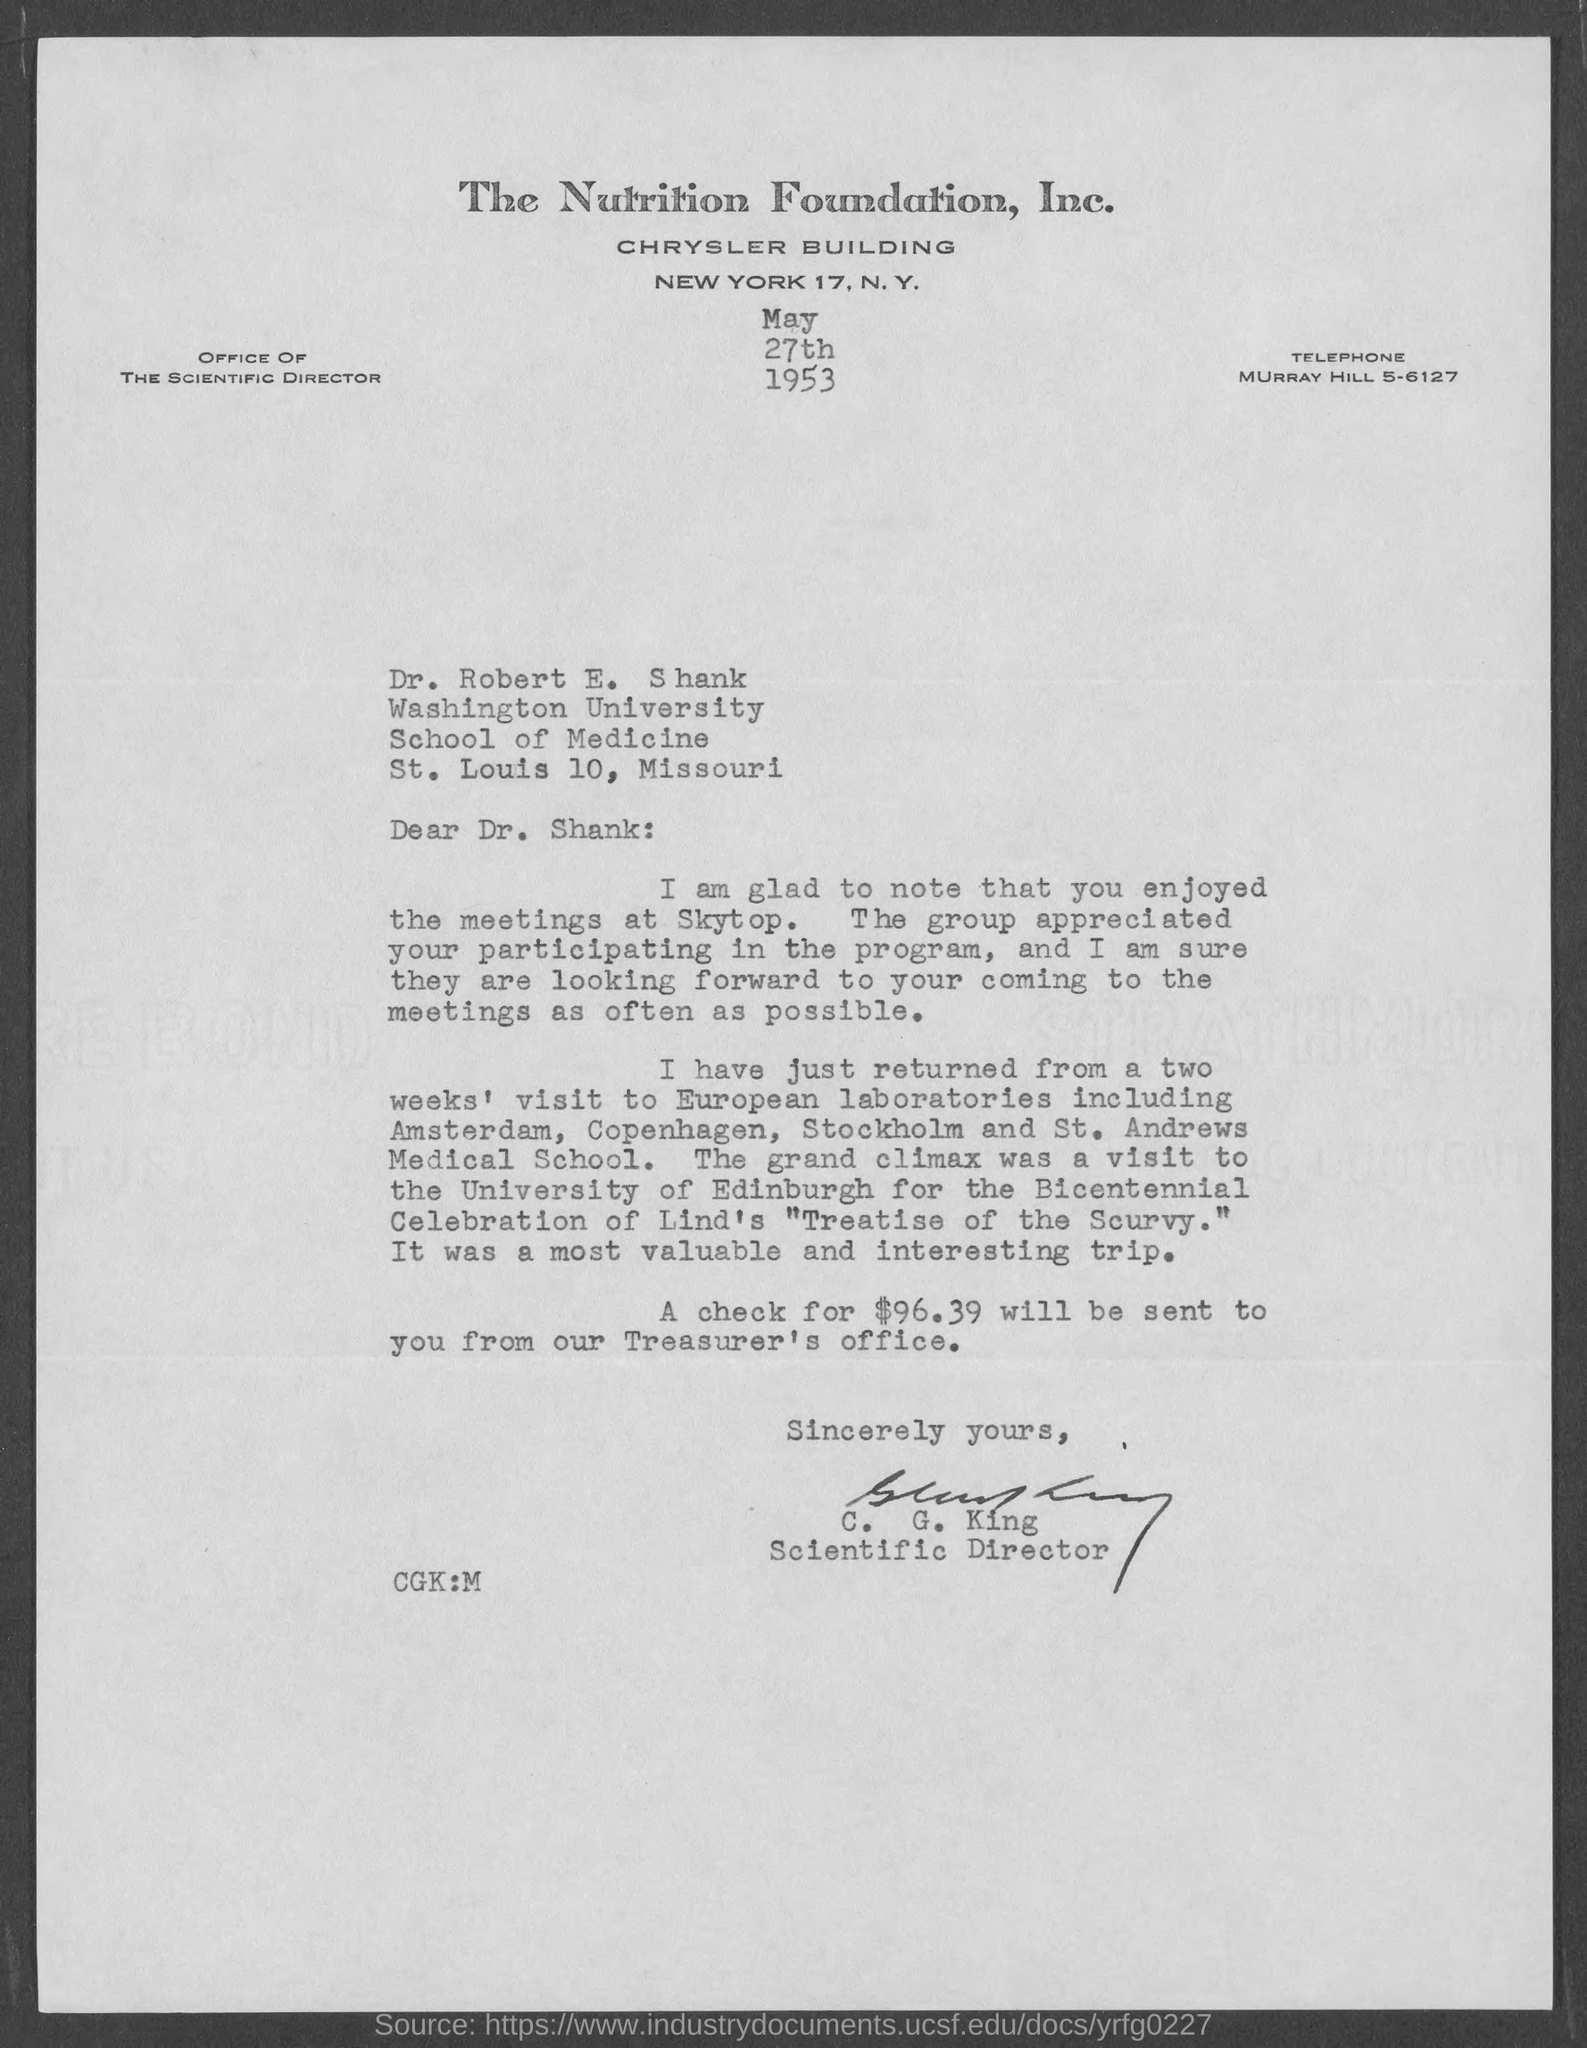Highlight a few significant elements in this photo. The amount of the check that would be sent from the Treasurer's office is $96.39. The letter is addressed to Dr. Robert E. Shank. 